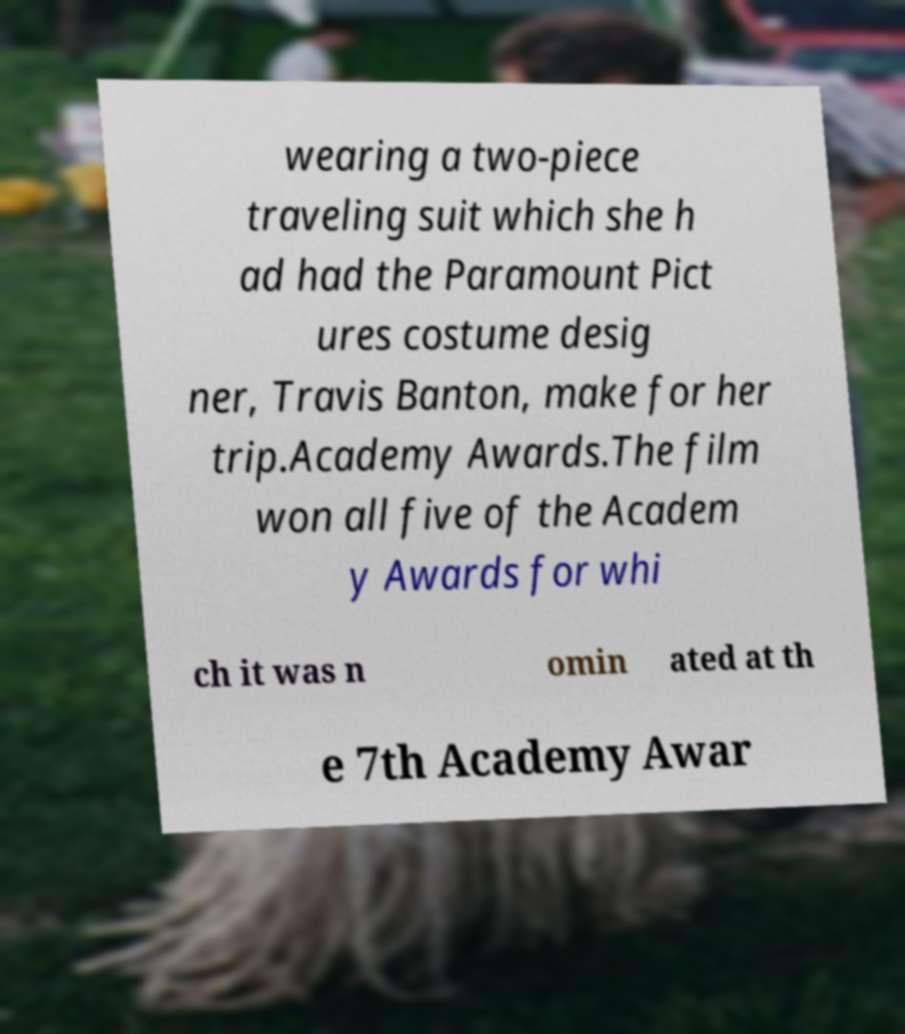For documentation purposes, I need the text within this image transcribed. Could you provide that? wearing a two-piece traveling suit which she h ad had the Paramount Pict ures costume desig ner, Travis Banton, make for her trip.Academy Awards.The film won all five of the Academ y Awards for whi ch it was n omin ated at th e 7th Academy Awar 